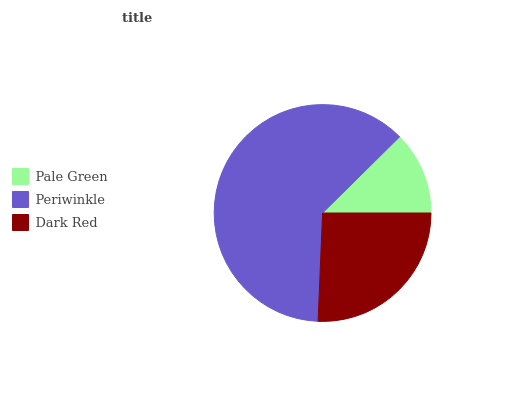Is Pale Green the minimum?
Answer yes or no. Yes. Is Periwinkle the maximum?
Answer yes or no. Yes. Is Dark Red the minimum?
Answer yes or no. No. Is Dark Red the maximum?
Answer yes or no. No. Is Periwinkle greater than Dark Red?
Answer yes or no. Yes. Is Dark Red less than Periwinkle?
Answer yes or no. Yes. Is Dark Red greater than Periwinkle?
Answer yes or no. No. Is Periwinkle less than Dark Red?
Answer yes or no. No. Is Dark Red the high median?
Answer yes or no. Yes. Is Dark Red the low median?
Answer yes or no. Yes. Is Pale Green the high median?
Answer yes or no. No. Is Periwinkle the low median?
Answer yes or no. No. 